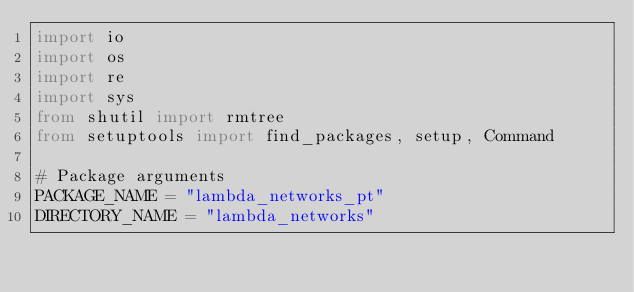<code> <loc_0><loc_0><loc_500><loc_500><_Python_>import io
import os
import re
import sys
from shutil import rmtree
from setuptools import find_packages, setup, Command

# Package arguments
PACKAGE_NAME = "lambda_networks_pt"
DIRECTORY_NAME = "lambda_networks"</code> 